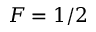Convert formula to latex. <formula><loc_0><loc_0><loc_500><loc_500>F = 1 / 2</formula> 